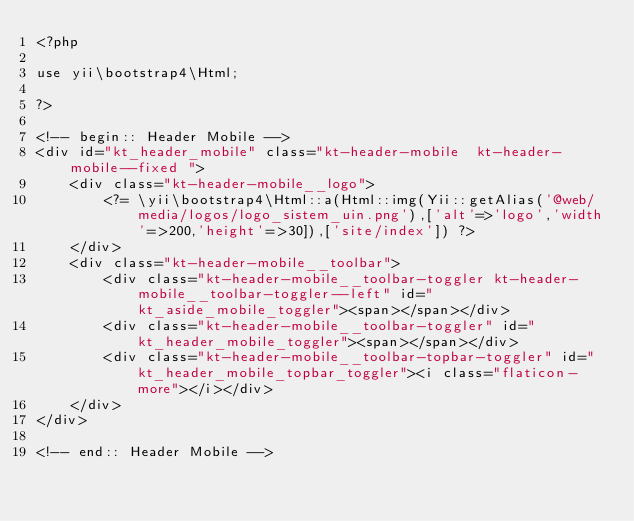<code> <loc_0><loc_0><loc_500><loc_500><_PHP_><?php

use yii\bootstrap4\Html;

?>

<!-- begin:: Header Mobile -->
<div id="kt_header_mobile" class="kt-header-mobile  kt-header-mobile--fixed ">
    <div class="kt-header-mobile__logo">
        <?= \yii\bootstrap4\Html::a(Html::img(Yii::getAlias('@web/media/logos/logo_sistem_uin.png'),['alt'=>'logo','width'=>200,'height'=>30]),['site/index']) ?>
    </div>
    <div class="kt-header-mobile__toolbar">
        <div class="kt-header-mobile__toolbar-toggler kt-header-mobile__toolbar-toggler--left" id="kt_aside_mobile_toggler"><span></span></div>
        <div class="kt-header-mobile__toolbar-toggler" id="kt_header_mobile_toggler"><span></span></div>
        <div class="kt-header-mobile__toolbar-topbar-toggler" id="kt_header_mobile_topbar_toggler"><i class="flaticon-more"></i></div>
    </div>
</div>

<!-- end:: Header Mobile --></code> 